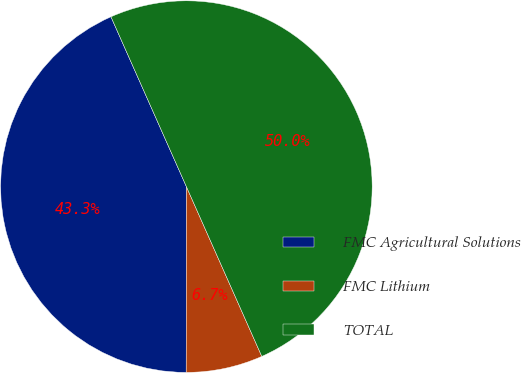<chart> <loc_0><loc_0><loc_500><loc_500><pie_chart><fcel>FMC Agricultural Solutions<fcel>FMC Lithium<fcel>TOTAL<nl><fcel>43.33%<fcel>6.67%<fcel>50.0%<nl></chart> 